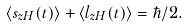Convert formula to latex. <formula><loc_0><loc_0><loc_500><loc_500>\langle s _ { z H } ( t ) \rangle + \langle l _ { z H } ( t ) \rangle = \hbar { / } 2 .</formula> 